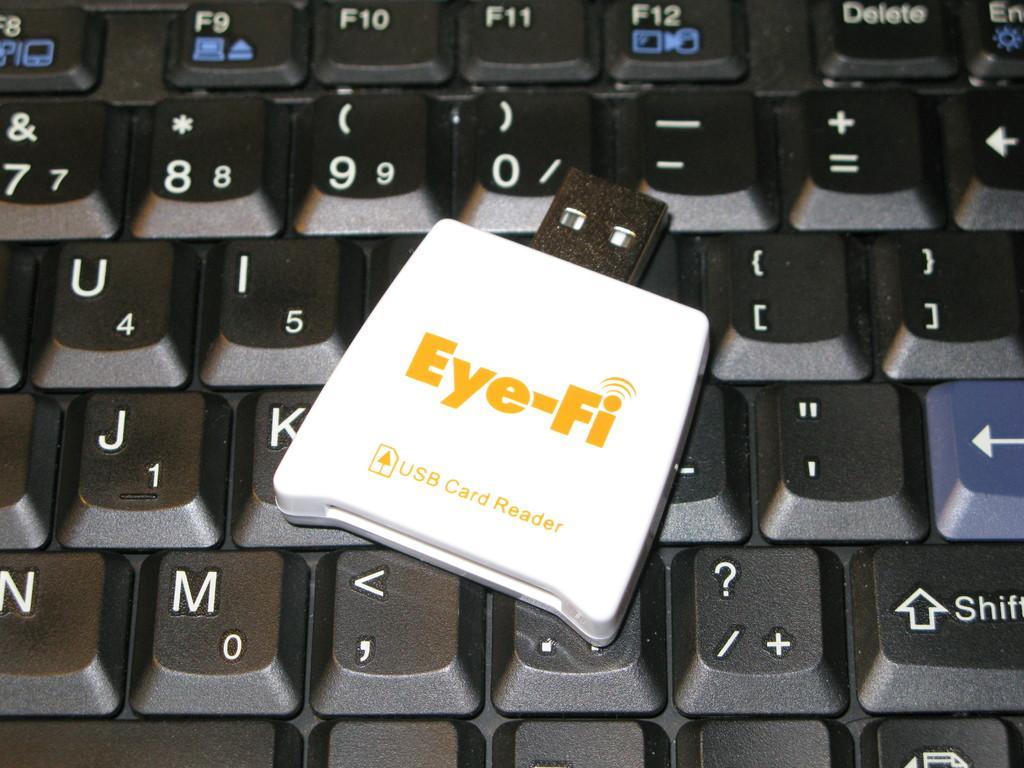Describe this image in one or two sentences. In this image there is a keyboard truncated, there is a card reader on the keyboard. 